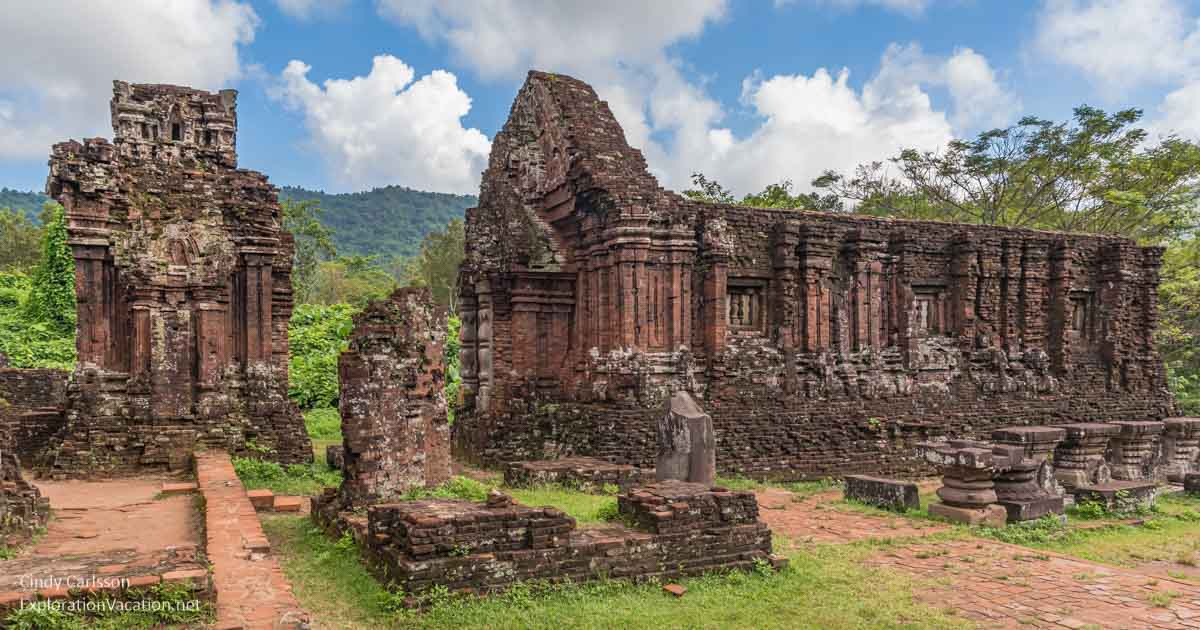What might have been the use of this structure at the height of its operation? During its zenith, the My Son temple complex served as a significant spiritual and cultural center for the Cham civilization. It was primarily used for religious ceremonies and was dedicated to Hindu deities, particularly to Shiva, whom the Cham people revered as a protector of their kings. Its intricate architecture and carvings suggest it also played a role in the political life of the society, possibly as a locale for important communal decisions and gatherings. 